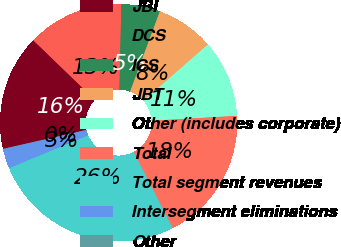Convert chart to OTSL. <chart><loc_0><loc_0><loc_500><loc_500><pie_chart><fcel>JBI<fcel>DCS<fcel>ICS<fcel>JBT<fcel>Other (includes corporate)<fcel>Total<fcel>Total segment revenues<fcel>Intersegment eliminations<fcel>Other<nl><fcel>15.77%<fcel>13.15%<fcel>5.29%<fcel>7.91%<fcel>10.53%<fcel>18.39%<fcel>26.25%<fcel>2.67%<fcel>0.05%<nl></chart> 